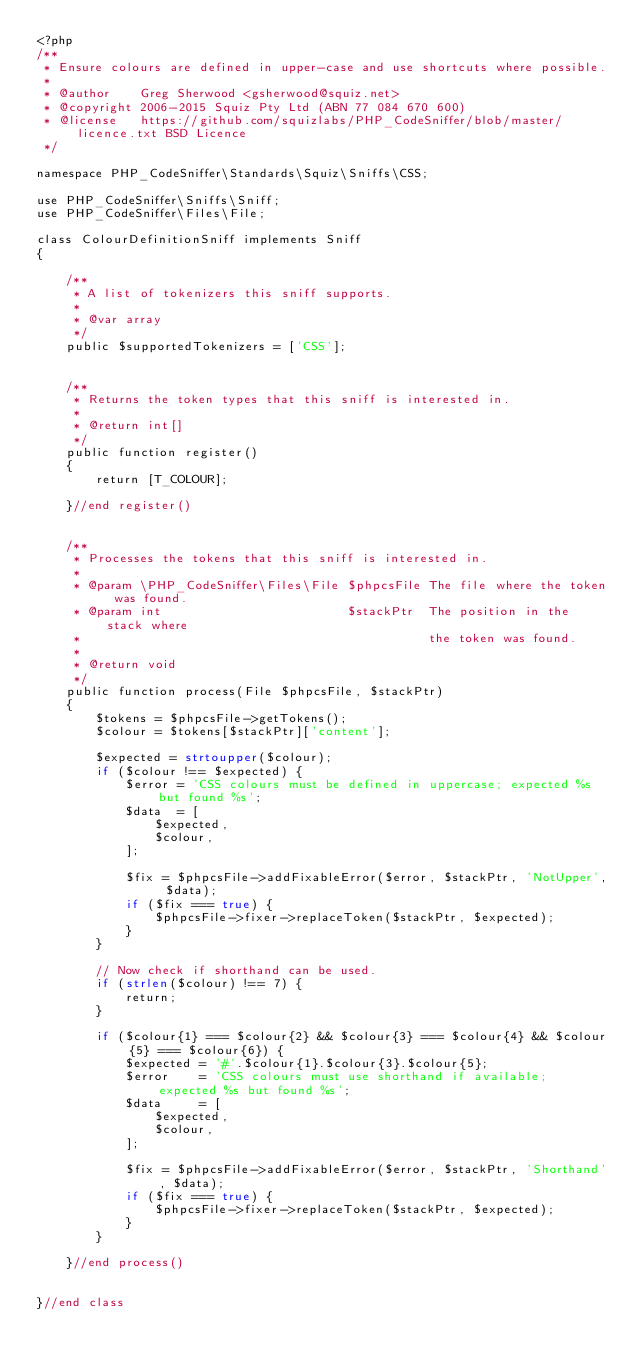Convert code to text. <code><loc_0><loc_0><loc_500><loc_500><_PHP_><?php
/**
 * Ensure colours are defined in upper-case and use shortcuts where possible.
 *
 * @author    Greg Sherwood <gsherwood@squiz.net>
 * @copyright 2006-2015 Squiz Pty Ltd (ABN 77 084 670 600)
 * @license   https://github.com/squizlabs/PHP_CodeSniffer/blob/master/licence.txt BSD Licence
 */

namespace PHP_CodeSniffer\Standards\Squiz\Sniffs\CSS;

use PHP_CodeSniffer\Sniffs\Sniff;
use PHP_CodeSniffer\Files\File;

class ColourDefinitionSniff implements Sniff
{

    /**
     * A list of tokenizers this sniff supports.
     *
     * @var array
     */
    public $supportedTokenizers = ['CSS'];


    /**
     * Returns the token types that this sniff is interested in.
     *
     * @return int[]
     */
    public function register()
    {
        return [T_COLOUR];

    }//end register()


    /**
     * Processes the tokens that this sniff is interested in.
     *
     * @param \PHP_CodeSniffer\Files\File $phpcsFile The file where the token was found.
     * @param int                         $stackPtr  The position in the stack where
     *                                               the token was found.
     *
     * @return void
     */
    public function process(File $phpcsFile, $stackPtr)
    {
        $tokens = $phpcsFile->getTokens();
        $colour = $tokens[$stackPtr]['content'];

        $expected = strtoupper($colour);
        if ($colour !== $expected) {
            $error = 'CSS colours must be defined in uppercase; expected %s but found %s';
            $data  = [
                $expected,
                $colour,
            ];

            $fix = $phpcsFile->addFixableError($error, $stackPtr, 'NotUpper', $data);
            if ($fix === true) {
                $phpcsFile->fixer->replaceToken($stackPtr, $expected);
            }
        }

        // Now check if shorthand can be used.
        if (strlen($colour) !== 7) {
            return;
        }

        if ($colour{1} === $colour{2} && $colour{3} === $colour{4} && $colour{5} === $colour{6}) {
            $expected = '#'.$colour{1}.$colour{3}.$colour{5};
            $error    = 'CSS colours must use shorthand if available; expected %s but found %s';
            $data     = [
                $expected,
                $colour,
            ];

            $fix = $phpcsFile->addFixableError($error, $stackPtr, 'Shorthand', $data);
            if ($fix === true) {
                $phpcsFile->fixer->replaceToken($stackPtr, $expected);
            }
        }

    }//end process()


}//end class
</code> 